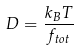Convert formula to latex. <formula><loc_0><loc_0><loc_500><loc_500>D = \frac { k _ { B } T } { f _ { t o t } }</formula> 